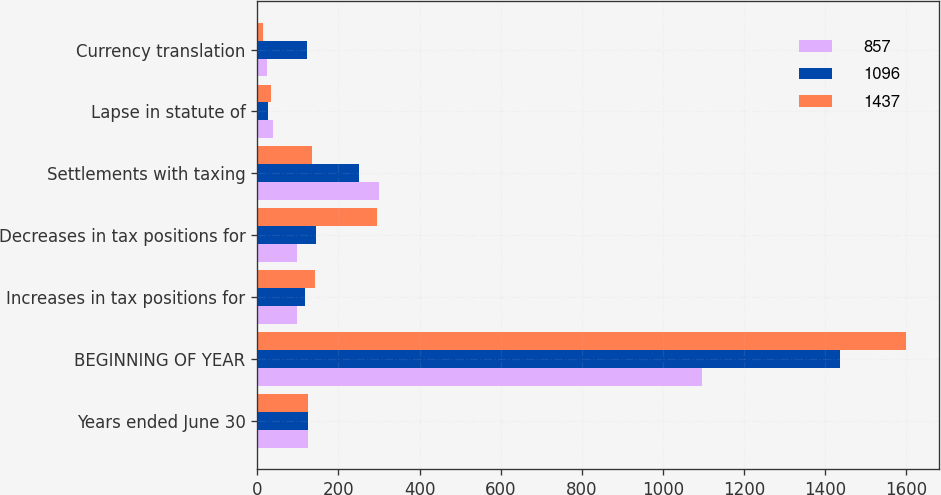Convert chart to OTSL. <chart><loc_0><loc_0><loc_500><loc_500><stacked_bar_chart><ecel><fcel>Years ended June 30<fcel>BEGINNING OF YEAR<fcel>Increases in tax positions for<fcel>Decreases in tax positions for<fcel>Settlements with taxing<fcel>Lapse in statute of<fcel>Currency translation<nl><fcel>857<fcel>124<fcel>1096<fcel>97<fcel>97<fcel>301<fcel>39<fcel>23<nl><fcel>1096<fcel>124<fcel>1437<fcel>118<fcel>146<fcel>250<fcel>27<fcel>123<nl><fcel>1437<fcel>124<fcel>1600<fcel>142<fcel>296<fcel>135<fcel>33<fcel>13<nl></chart> 